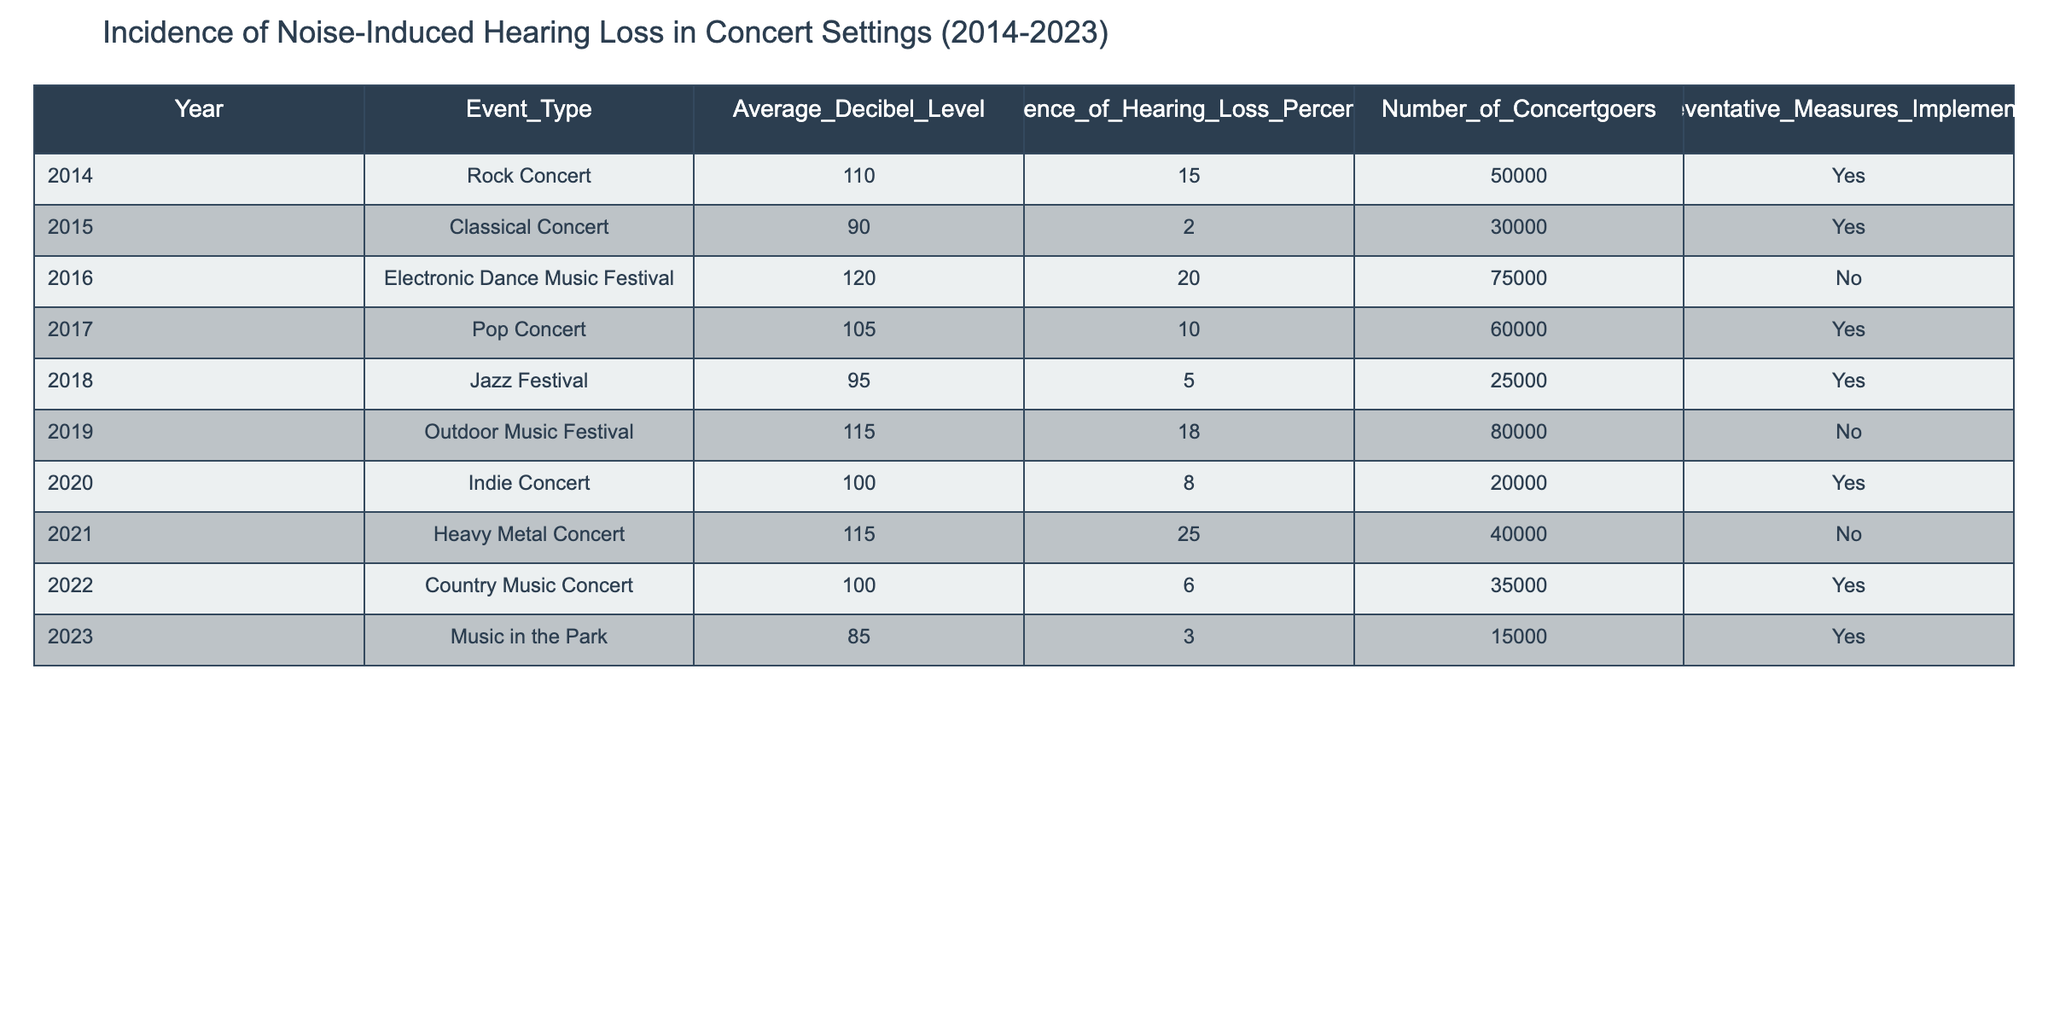What was the average decibel level for concerts in 2022? In the table, the decibel level for the Country Music Concert in 2022 is 100. Since there is only one concert listed for that year, the average is just that value.
Answer: 100 What percentage of concertgoers experienced hearing loss at the Electronic Dance Music Festival in 2016? The table shows that the incidence of hearing loss at the Electronic Dance Music Festival in 2016 was 20%. Therefore, that percentage is directly from the table.
Answer: 20 Which year had the highest incidence of hearing loss and what was that percentage? Review the incidence percentages from the table: 15, 2, 20, 10, 5, 18, 8, 25, 6, and 3. The highest value is 25% in 2021 for the Heavy Metal Concert.
Answer: 2021, 25 Was there a preventative measure implemented for the Pop Concert in 2017? According to the table, yes, there was a preventative measure implemented for the Pop Concert in 2017. This can be found directly in the corresponding entry for that event.
Answer: Yes What is the average incidence of hearing loss across all years listed in the table? First, sum all the incidence percentages: 15 + 2 + 20 + 10 + 5 + 18 + 8 + 25 + 6 + 3 = 112. There are 10 events (years), so divide the total by 10: 112 / 10 = 11.2.
Answer: 11.2 Did the Rock Concert in 2014 implement preventative measures and how many concertgoers attended? Yes, the Rock Concert in 2014 did implement preventative measures, and it had 50,000 concertgoers. These details can be found directly in the row associated with that concert.
Answer: Yes, 50000 Which genre had the lowest average decibel level and what was that level? To find this, calculate the average of the decibel levels for each genre: Rock (110), Classical (90), EDM (120), Pop (105), Jazz (95), Outdoor (115), Indie (100), Heavy Metal (115), Country (100), and Music in the Park (85). The lowest level is 85 for Music in the Park in 2023.
Answer: Music in the Park, 85 How many total concertgoers attended the concerts in the last decade? Add the number of concertgoers for each event: 50000 + 30000 + 75000 + 60000 + 25000 + 80000 + 20000 + 40000 + 35000 + 15000 = 360000. Thus, the total number of concertgoers is 360000.
Answer: 360000 What percentage of the concerts had preventative measures implemented? From the table, 7 out of 10 concerts had preventative measures. To find the percentage, divide 7 by 10 and then multiply by 100: (7/10) * 100 = 70%.
Answer: 70% 